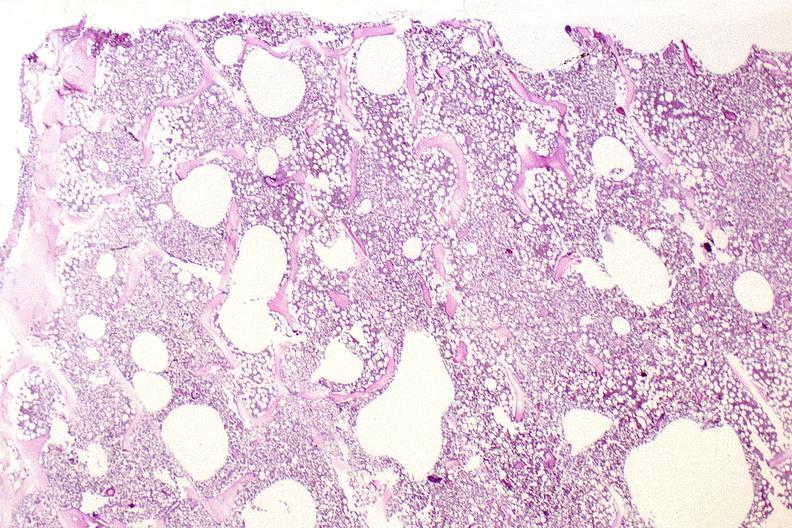does this image show bone, vertebral body opsteopenia, osteoporosis?
Answer the question using a single word or phrase. Yes 